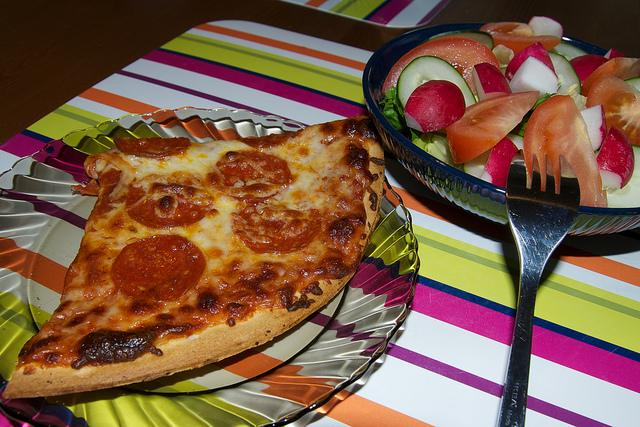What kind of side meal is there a serving of near the pizza? salad 